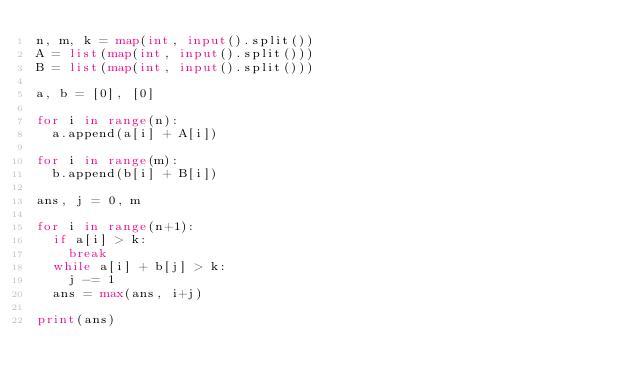Convert code to text. <code><loc_0><loc_0><loc_500><loc_500><_Python_>n, m, k = map(int, input().split())
A = list(map(int, input().split()))
B = list(map(int, input().split()))

a, b = [0], [0]

for i in range(n):
  a.append(a[i] + A[i])
  
for i in range(m):
  b.append(b[i] + B[i])
  
ans, j = 0, m

for i in range(n+1):
  if a[i] > k:
    break
  while a[i] + b[j] > k:
    j -= 1
  ans = max(ans, i+j)

print(ans)</code> 